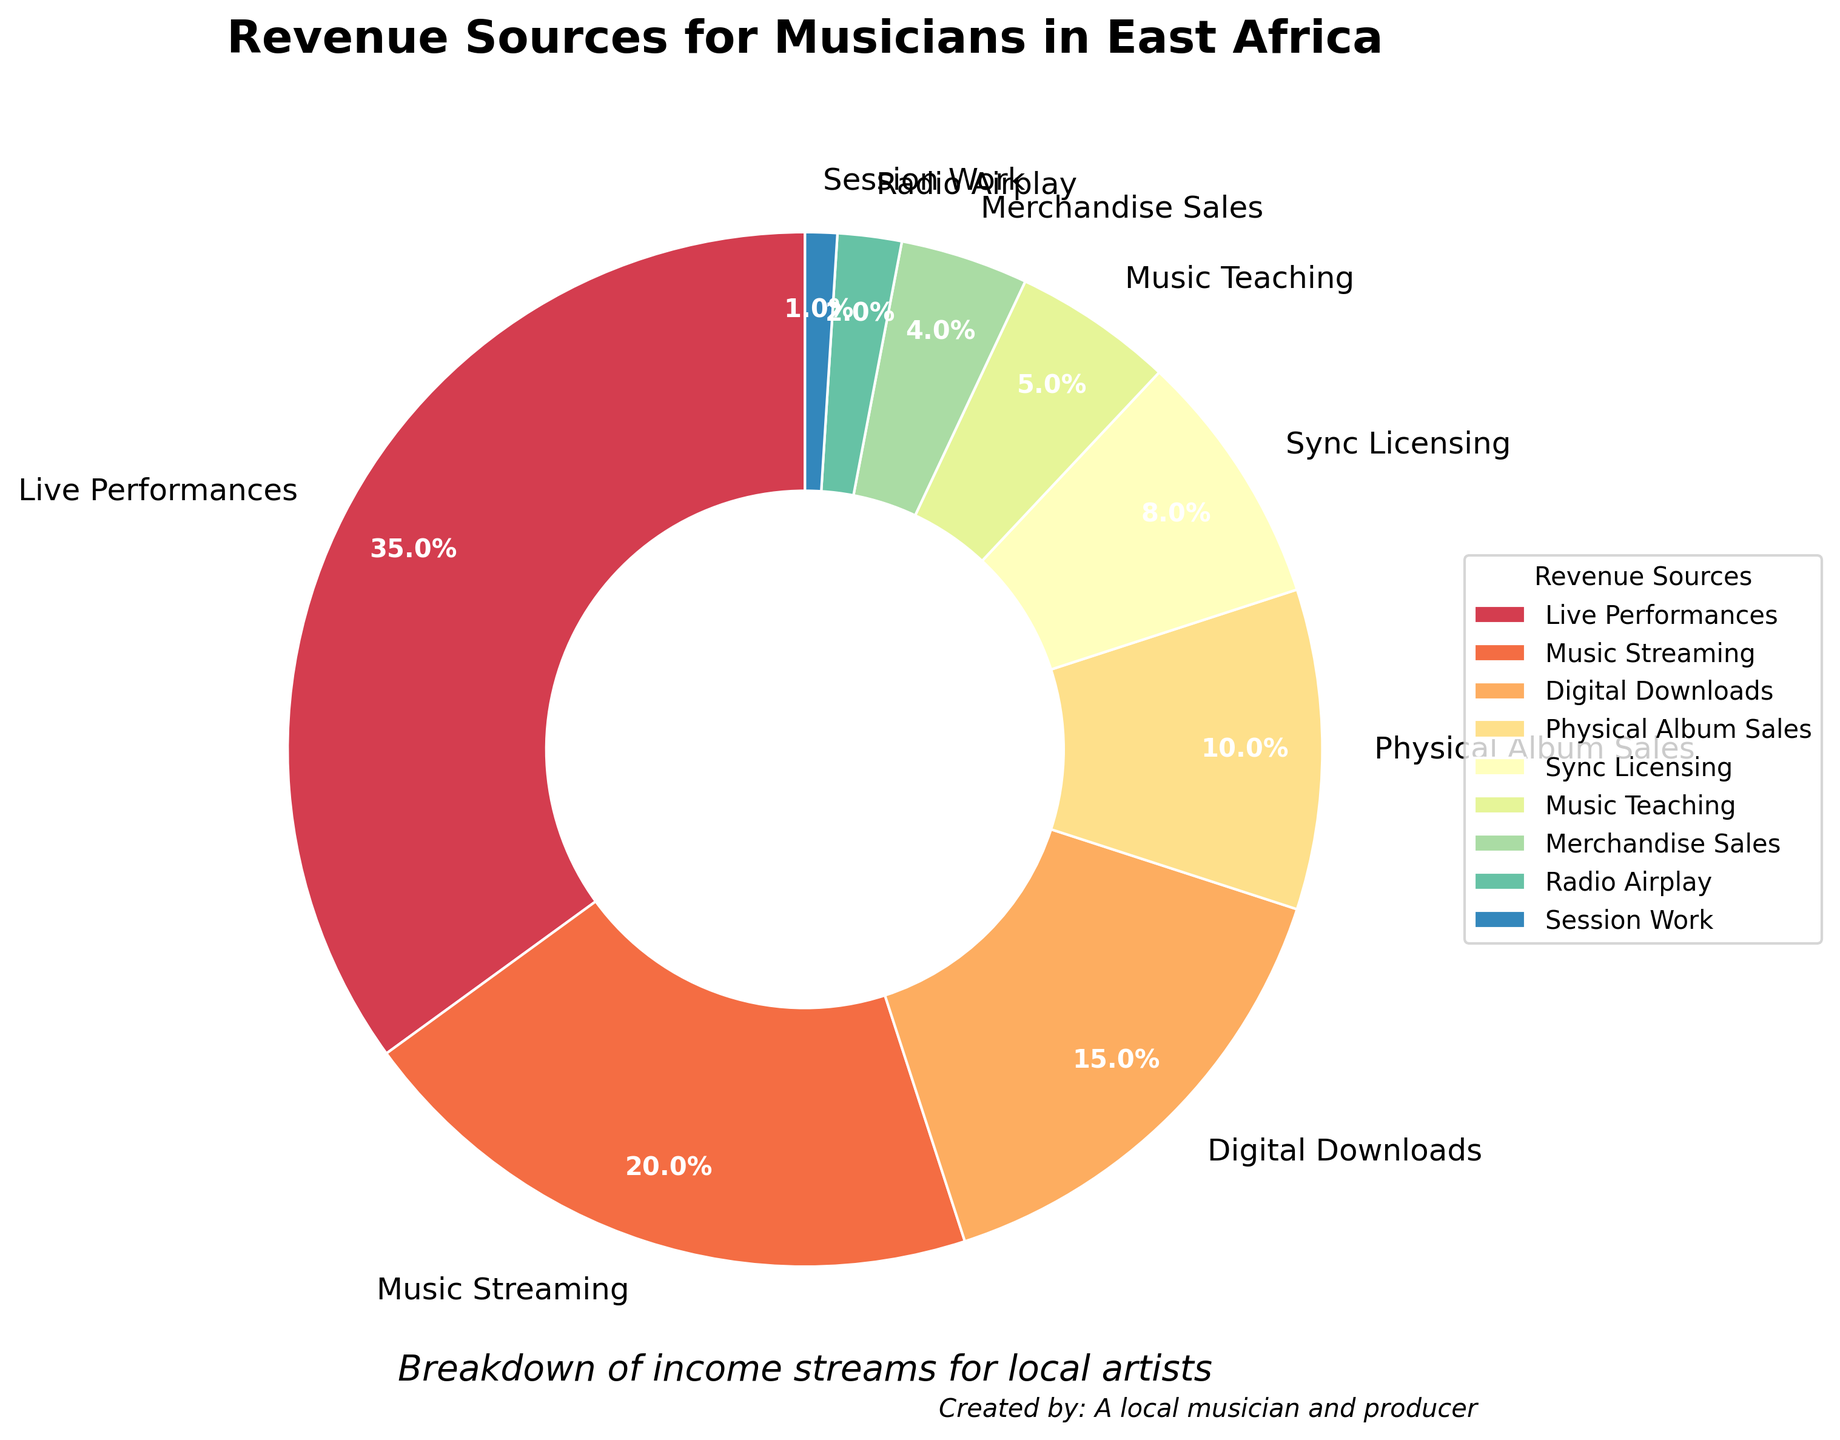What percentage of revenue comes from digital downloads and music streaming combined? Add the percentages for digital downloads and music streaming: 15% + 20% = 35%
Answer: 35% Which revenue source contributes more: live performances or merchandise sales? Compare the percentages for live performances (35%) and merchandise sales (4%): 35% > 4%
Answer: Live performances What is the least contributing revenue source, and what is its percentage? Identify the smallest percentage in the breakdown: session work with 1%
Answer: Session work, 1% Which revenue source contributes 10% of the total revenue? Look for the revenue source with a 10% contribution: physical album sales
Answer: Physical album sales By how much does the revenue from music teaching exceed session work? Subtract the percentage of session work from music teaching: 5% - 1% = 4%
Answer: 4% How many revenue sources contribute less than 10% each? Count the revenue sources with percentages less than 10%: sync licensing, music teaching, merchandise sales, radio airplay, session work (total 5)
Answer: 5 What is the total percentage of revenue from sources that individually contribute less than 5%? Sum the percentages for merchandise sales, radio airplay, and session work: 4% + 2% + 1% = 7%
Answer: 7% Which is larger: the combined percentage of digital downloads and physical album sales, or the percentage of live performances? Calculate the combined percentage of digital downloads and physical album sales: 15% + 10% = 25%, then compare with live performances (35%): 25% < 35%
Answer: Live performances What are the top three revenue sources, and what are their individual percentages? Identify the three highest percentages: live performances (35%), music streaming (20%), digital downloads (15%)
Answer: Live performances (35%), music streaming (20%), digital downloads (15%) Among live performances, music streaming, and physical album sales, which one has the smallest contribution? Compare the percentages of live performances (35%), music streaming (20%), and physical album sales (10%): 10% is the smallest
Answer: Physical album sales 